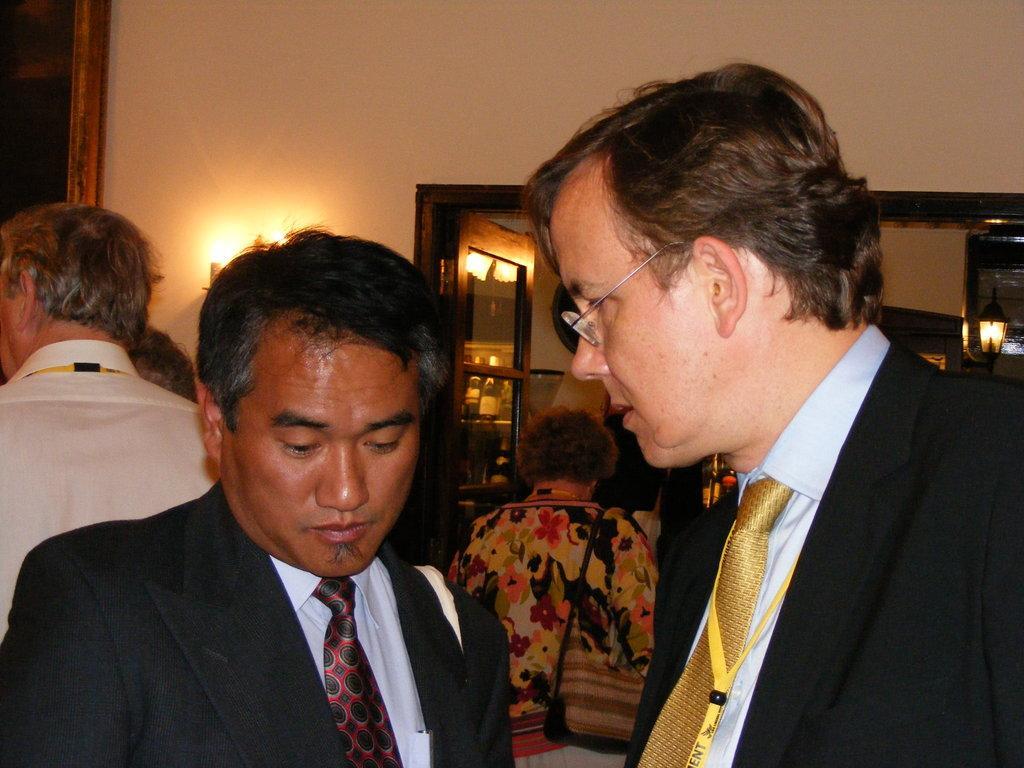In one or two sentences, can you explain what this image depicts? In this image I can see the group of people with different color dresses. In the background I can see the lights, bottles in the rack and the wall. 